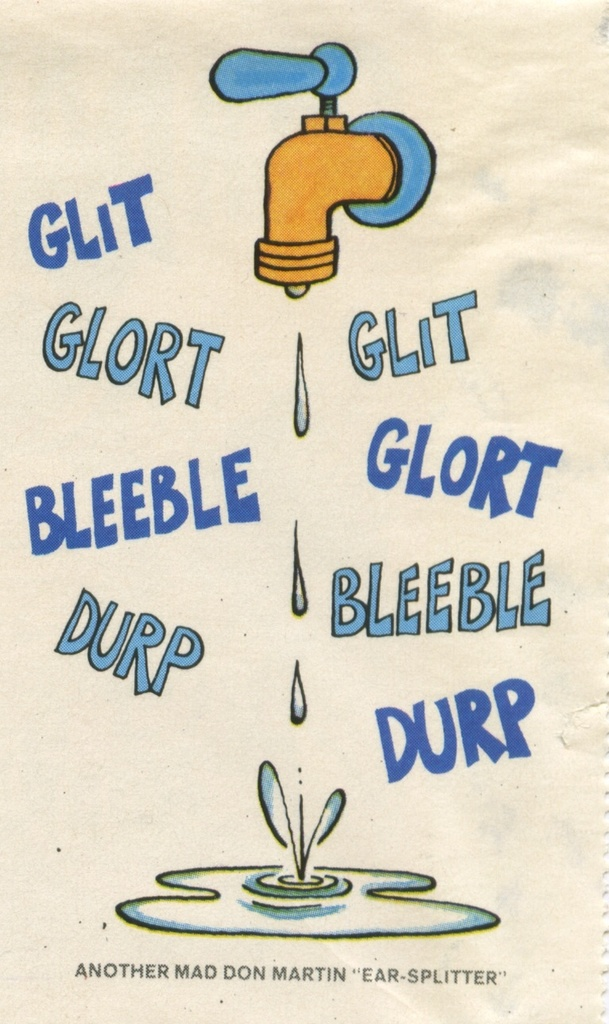What might be the significance of using the words 'glit', 'glort', 'bleeble', and 'durp' around the faucet? These words are onomatopoeic, each aiming to creatively mimic the sound of water drops as imagined by the artist. Their unique and nonsensical nature serves to amplify the humor, making the ordinary act of dripping sound more dramatic and noteworthy, thus enhancing the comic relief provided by the exaggerated sounds in this visual artwork. 